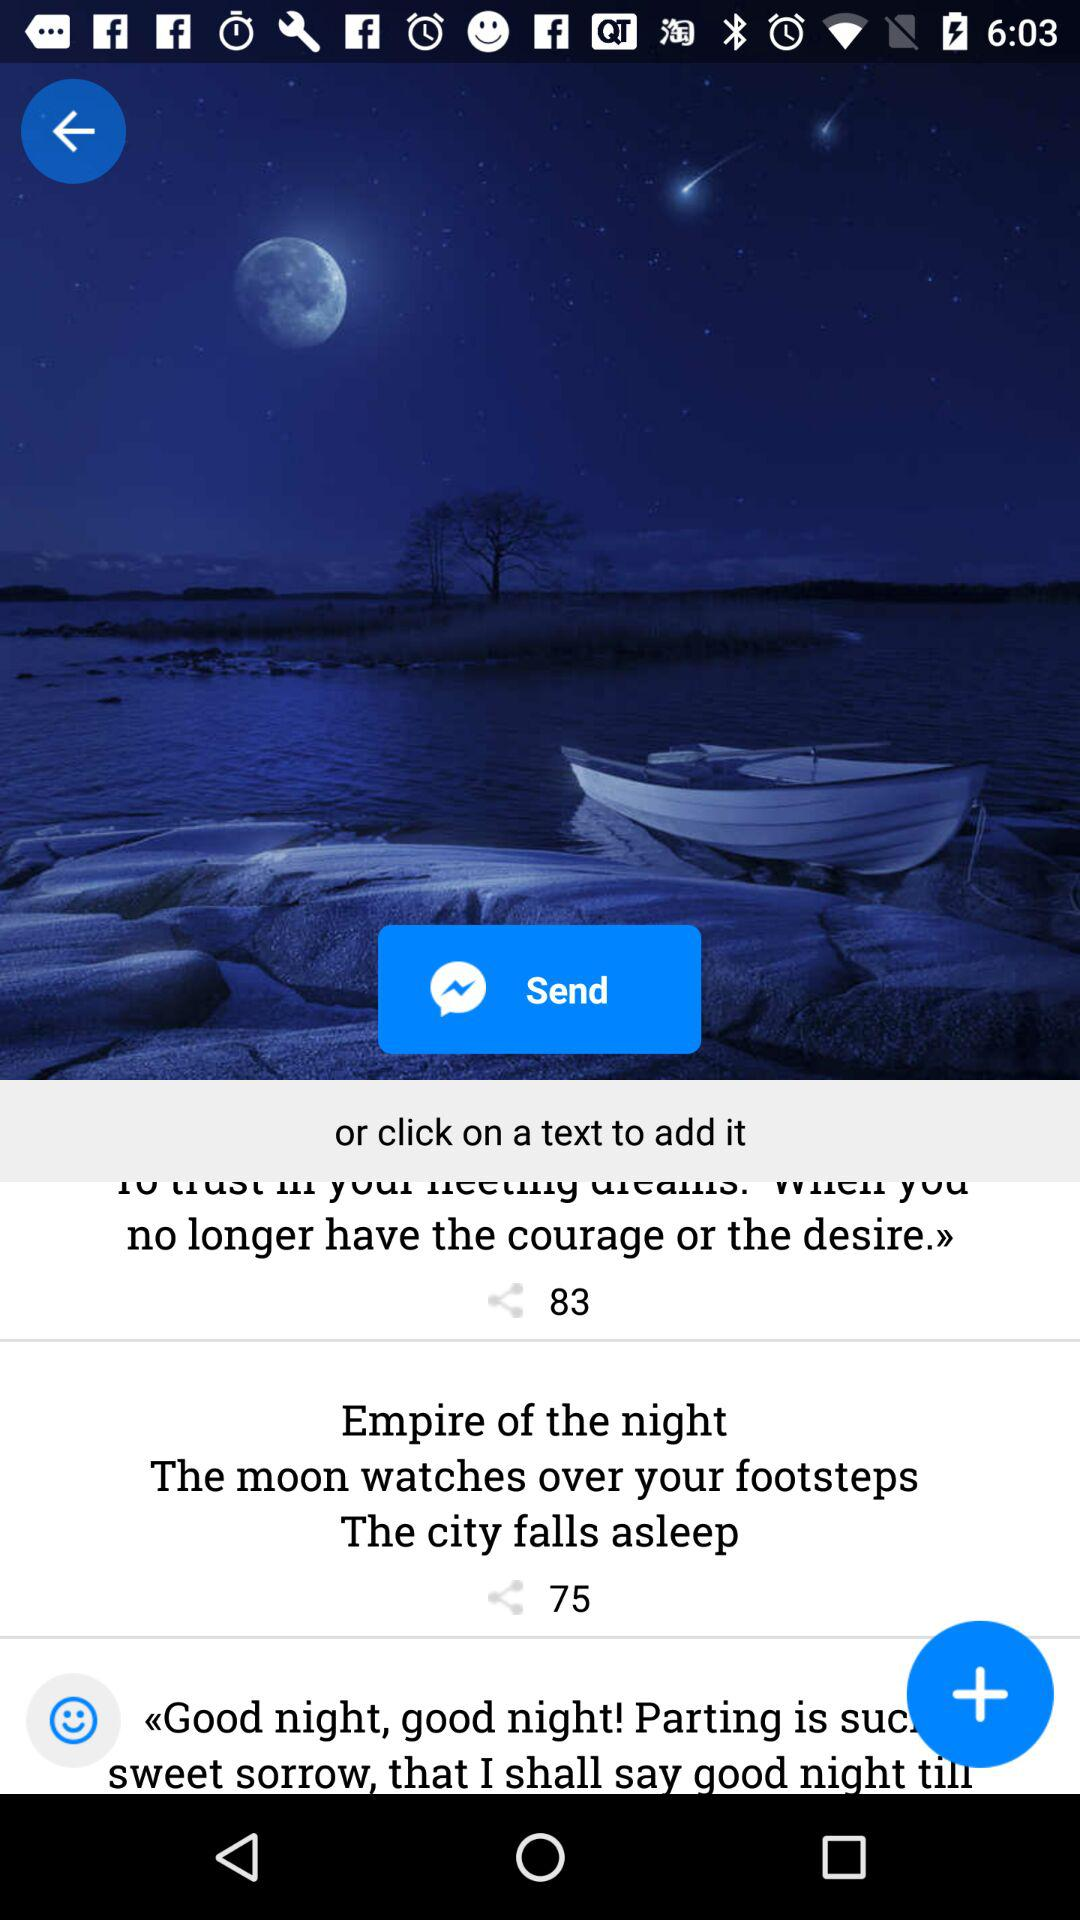How many people have shared the post "Empire of the night The moon watches over your footsteps The city falls asleep"? The post "Empire of the night The moon watches over your footsteps The city falls asleep" has been shared by 75 people. 